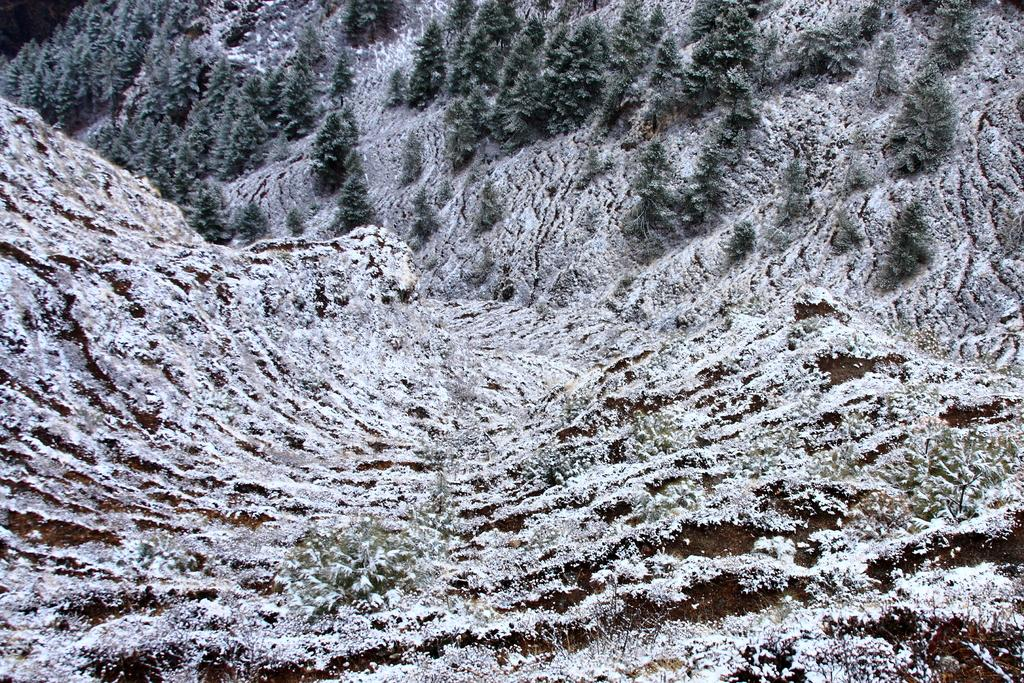What is the main subject of the image? The main subject of the image is a snowy mountain. What type of vegetation can be seen in the image? There are trees and small bushes visible in the image. How many lights can be seen on the snowy mountain in the image? There are no lights visible on the snowy mountain in the image. Can you see any flies in the image? There are no flies present in the image. 